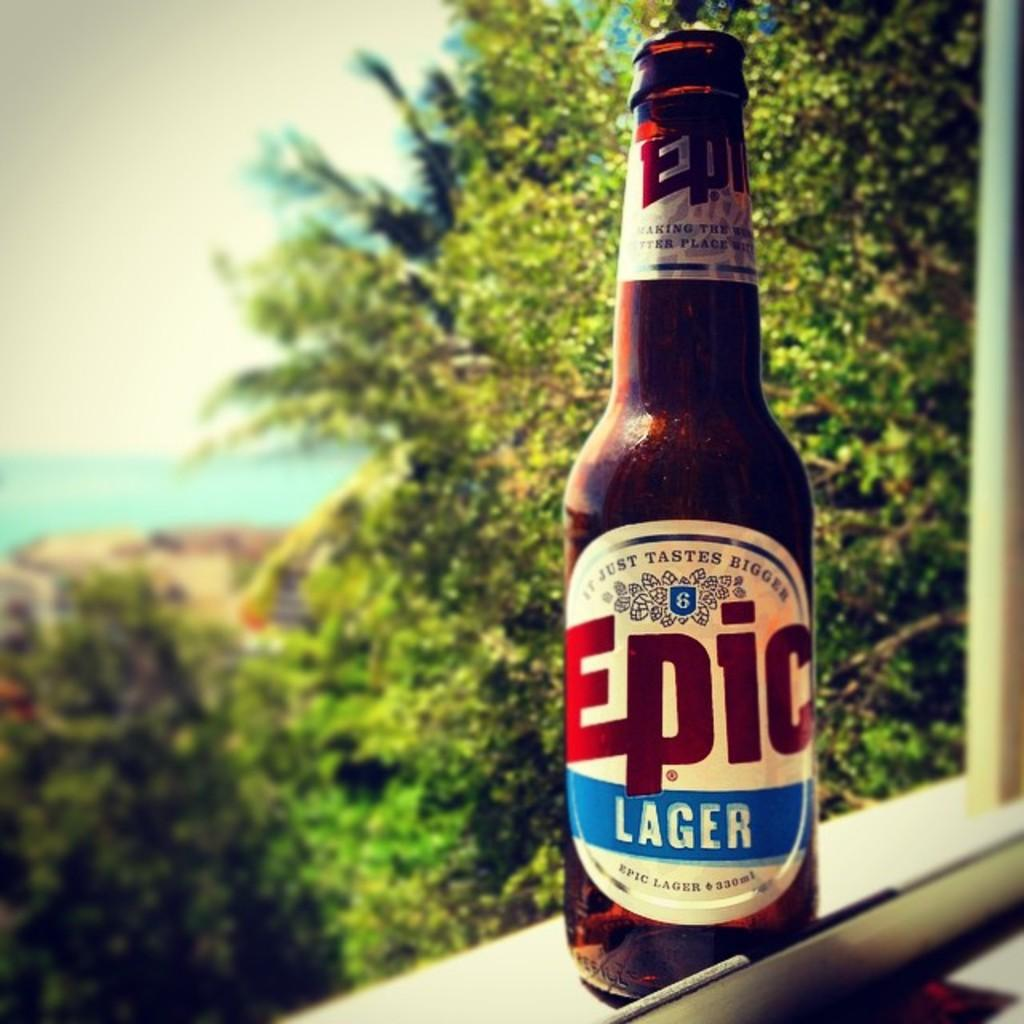<image>
Provide a brief description of the given image. a bottle of Epic Lager in a window sill 